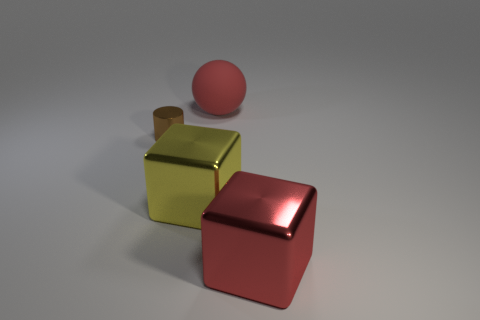Add 4 big yellow metallic blocks. How many objects exist? 8 Subtract all balls. How many objects are left? 3 Add 4 large cyan matte balls. How many large cyan matte balls exist? 4 Subtract 0 gray cubes. How many objects are left? 4 Subtract all yellow metal objects. Subtract all red metal blocks. How many objects are left? 2 Add 1 large red rubber objects. How many large red rubber objects are left? 2 